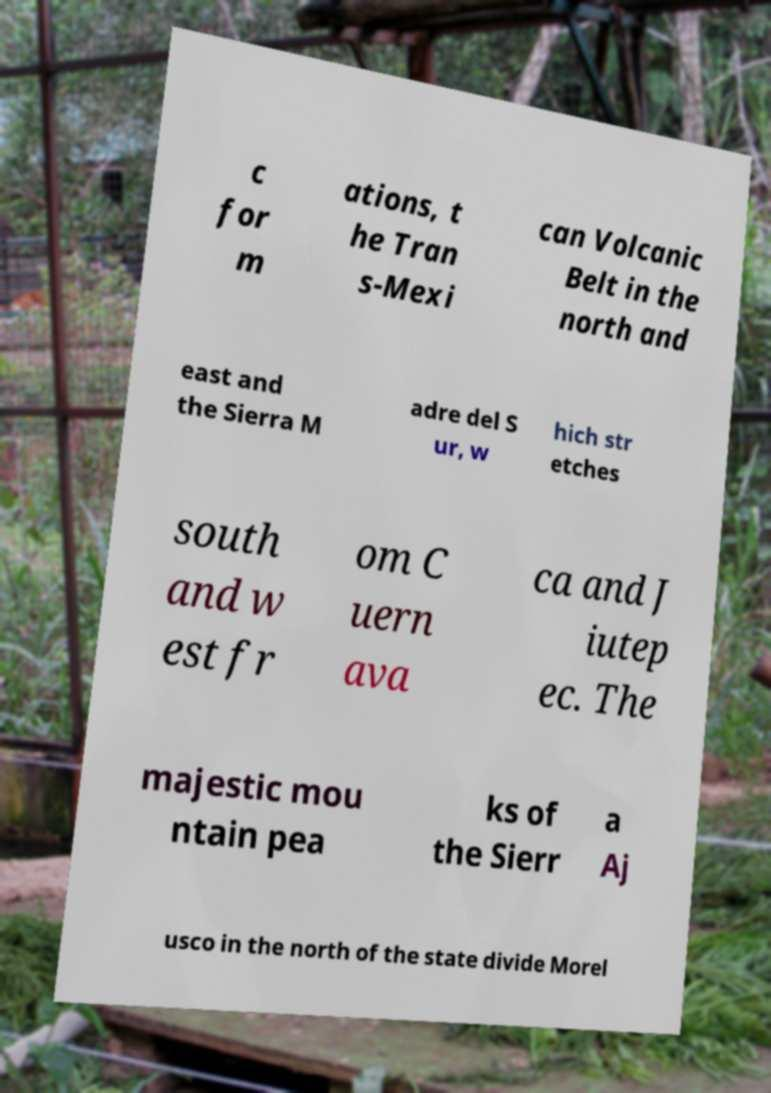Please read and relay the text visible in this image. What does it say? c for m ations, t he Tran s-Mexi can Volcanic Belt in the north and east and the Sierra M adre del S ur, w hich str etches south and w est fr om C uern ava ca and J iutep ec. The majestic mou ntain pea ks of the Sierr a Aj usco in the north of the state divide Morel 